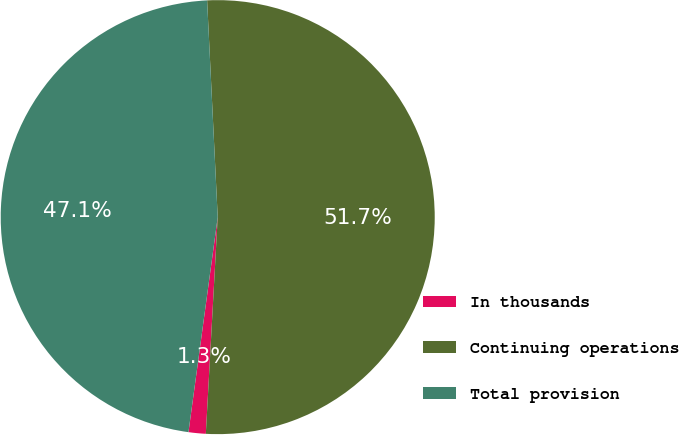Convert chart. <chart><loc_0><loc_0><loc_500><loc_500><pie_chart><fcel>In thousands<fcel>Continuing operations<fcel>Total provision<nl><fcel>1.28%<fcel>51.65%<fcel>47.07%<nl></chart> 